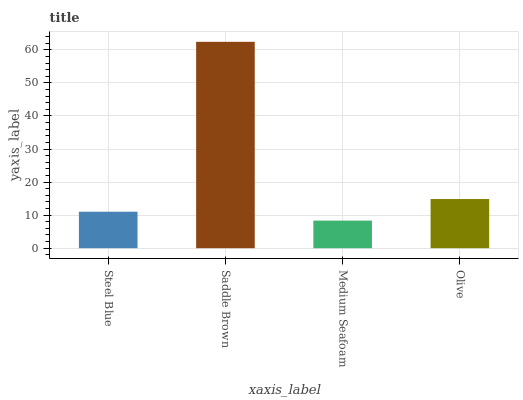Is Medium Seafoam the minimum?
Answer yes or no. Yes. Is Saddle Brown the maximum?
Answer yes or no. Yes. Is Saddle Brown the minimum?
Answer yes or no. No. Is Medium Seafoam the maximum?
Answer yes or no. No. Is Saddle Brown greater than Medium Seafoam?
Answer yes or no. Yes. Is Medium Seafoam less than Saddle Brown?
Answer yes or no. Yes. Is Medium Seafoam greater than Saddle Brown?
Answer yes or no. No. Is Saddle Brown less than Medium Seafoam?
Answer yes or no. No. Is Olive the high median?
Answer yes or no. Yes. Is Steel Blue the low median?
Answer yes or no. Yes. Is Saddle Brown the high median?
Answer yes or no. No. Is Olive the low median?
Answer yes or no. No. 